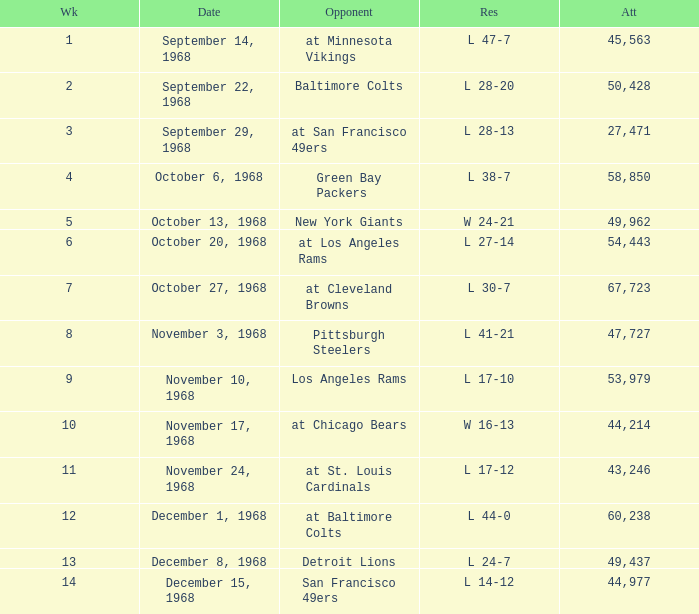Which Attendance has an Opponent of new york giants, and a Week smaller than 5? None. Could you parse the entire table? {'header': ['Wk', 'Date', 'Opponent', 'Res', 'Att'], 'rows': [['1', 'September 14, 1968', 'at Minnesota Vikings', 'L 47-7', '45,563'], ['2', 'September 22, 1968', 'Baltimore Colts', 'L 28-20', '50,428'], ['3', 'September 29, 1968', 'at San Francisco 49ers', 'L 28-13', '27,471'], ['4', 'October 6, 1968', 'Green Bay Packers', 'L 38-7', '58,850'], ['5', 'October 13, 1968', 'New York Giants', 'W 24-21', '49,962'], ['6', 'October 20, 1968', 'at Los Angeles Rams', 'L 27-14', '54,443'], ['7', 'October 27, 1968', 'at Cleveland Browns', 'L 30-7', '67,723'], ['8', 'November 3, 1968', 'Pittsburgh Steelers', 'L 41-21', '47,727'], ['9', 'November 10, 1968', 'Los Angeles Rams', 'L 17-10', '53,979'], ['10', 'November 17, 1968', 'at Chicago Bears', 'W 16-13', '44,214'], ['11', 'November 24, 1968', 'at St. Louis Cardinals', 'L 17-12', '43,246'], ['12', 'December 1, 1968', 'at Baltimore Colts', 'L 44-0', '60,238'], ['13', 'December 8, 1968', 'Detroit Lions', 'L 24-7', '49,437'], ['14', 'December 15, 1968', 'San Francisco 49ers', 'L 14-12', '44,977']]} 